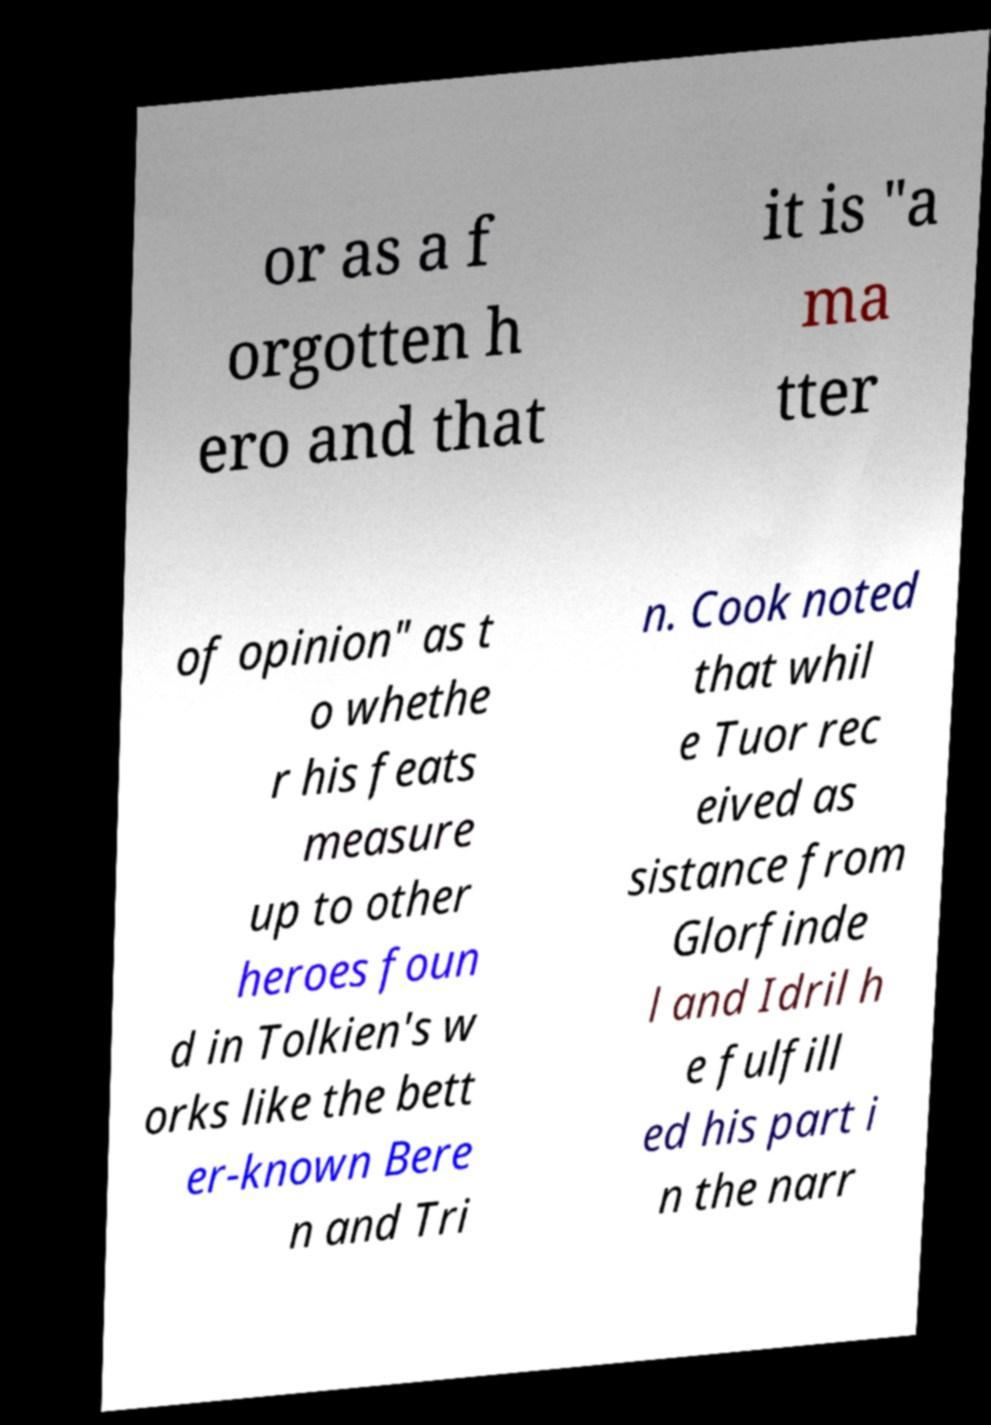Can you accurately transcribe the text from the provided image for me? or as a f orgotten h ero and that it is "a ma tter of opinion" as t o whethe r his feats measure up to other heroes foun d in Tolkien's w orks like the bett er-known Bere n and Tri n. Cook noted that whil e Tuor rec eived as sistance from Glorfinde l and Idril h e fulfill ed his part i n the narr 